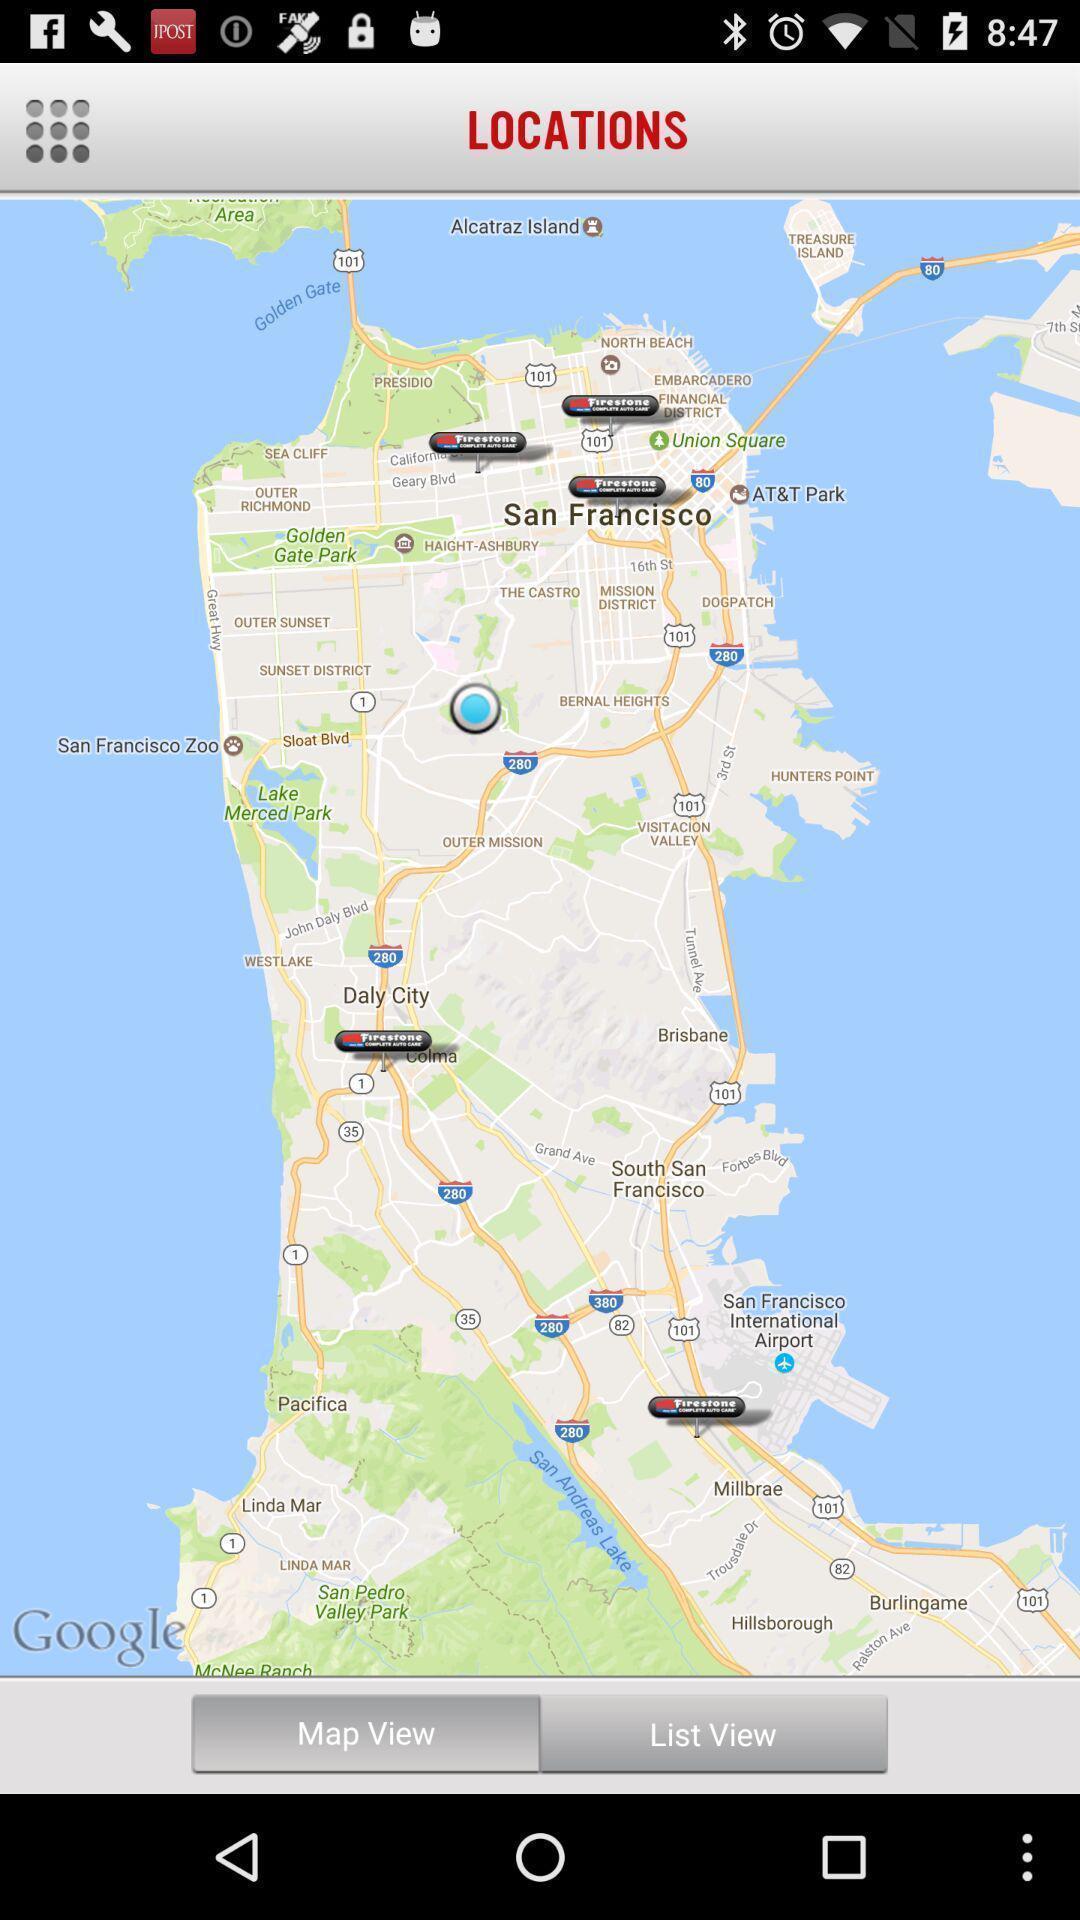Describe the content in this image. Screen shows locations on a navigation app. 